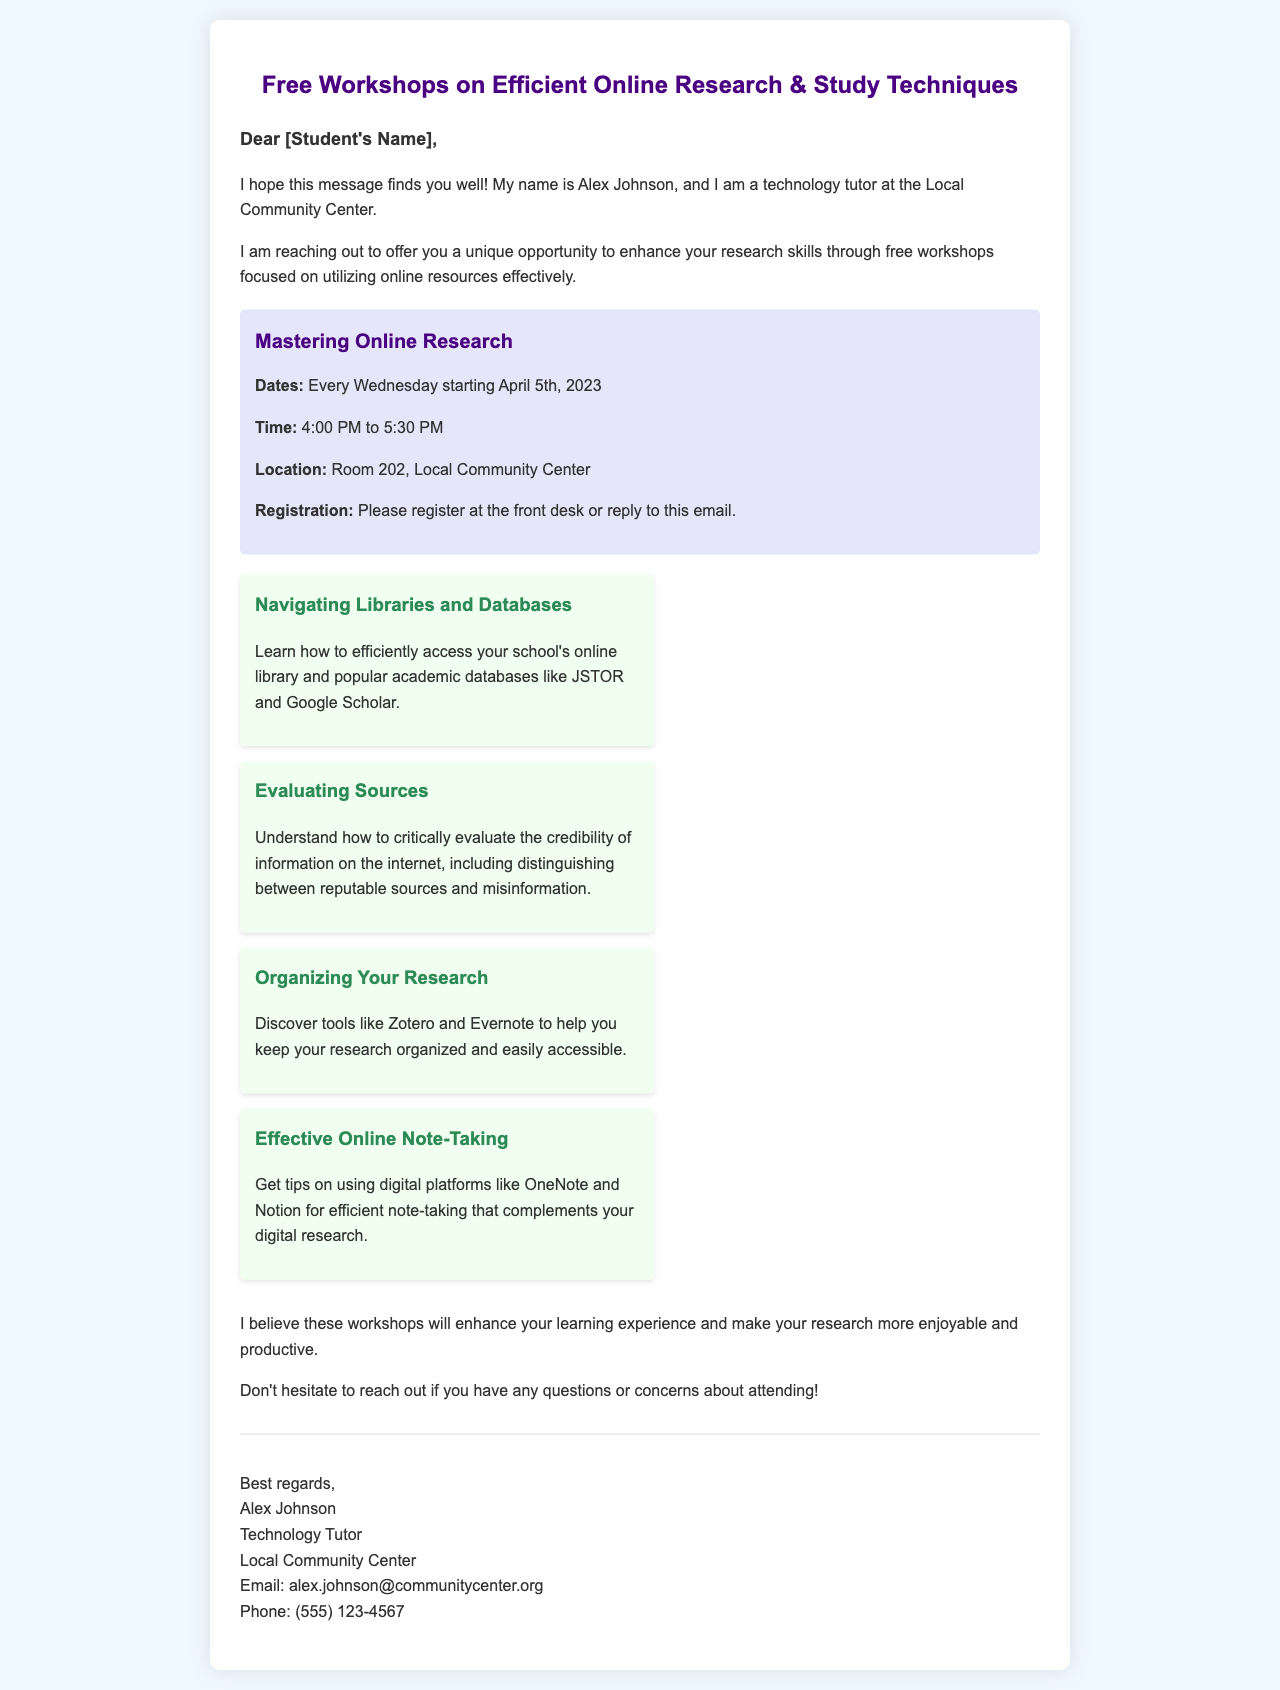What is the name of the technology tutor? The letter mentions Alex Johnson as the technology tutor offering the workshops.
Answer: Alex Johnson What is the location of the workshops? The workshops are held at Room 202 in the Local Community Center, as stated in the document.
Answer: Room 202, Local Community Center When do the workshops start? The workshops are scheduled to begin on April 5th, 2023, according to the workshop details provided.
Answer: April 5th, 2023 How long will each workshop last? Each workshop is indicated to last for an hour and a half, from 4:00 PM to 5:30 PM.
Answer: 1.5 hours What is one of the tools mentioned for organizing research? The document lists Zotero as one of the tools that can help in organizing research.
Answer: Zotero Why are the workshops being offered? The letter states that the workshops are intended to enhance research skills and improve the learning experience for students.
Answer: Enhance research skills What should a student do to register for the workshops? According to the letter, students can register by going to the front desk or replying to the email.
Answer: Register at the front desk or reply to the email What type of content will the workshops cover regarding evaluating information? The workshops will teach students how to critically evaluate the credibility of internet information, including reputable sources and misinformation.
Answer: Evaluating credibility of information What is the main purpose of the workshops? The main purpose outlined in the document is to make research more enjoyable and productive for students.
Answer: Enjoyable and productive research 